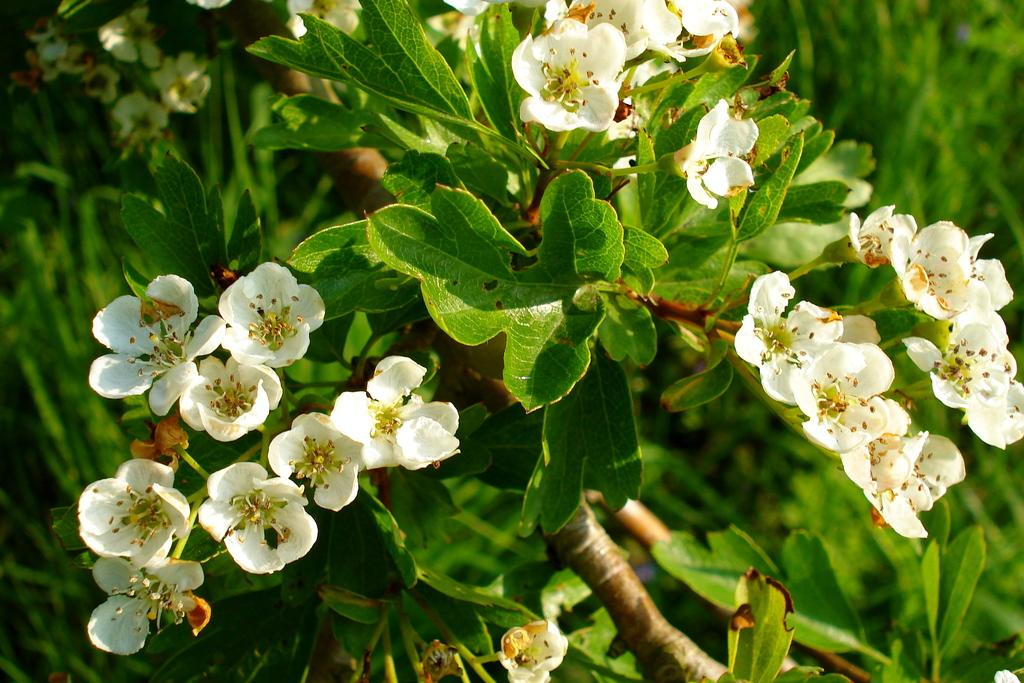What is present in the image? There is a plant in the image. What type of flowers does the plant have? The plant has white flowers. How many cubes are being used in a game of chess in the image? There is no chess game or cubes present in the image. What type of event is taking place in the image? There is no event present in the image; it simply features a plant with white flowers. 